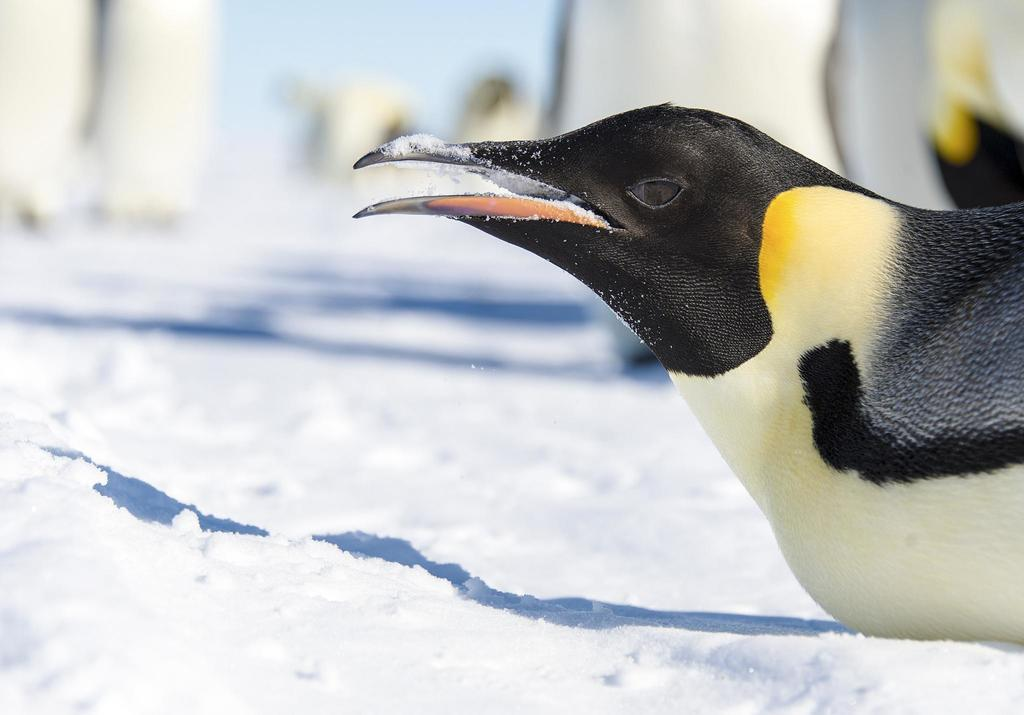What type of animal is in the image? There is a bird in the image. Where is the bird located? The bird is sitting on the snow. What type of badge is the bird wearing in the image? There is no badge present in the image; the bird is simply sitting on the snow. 